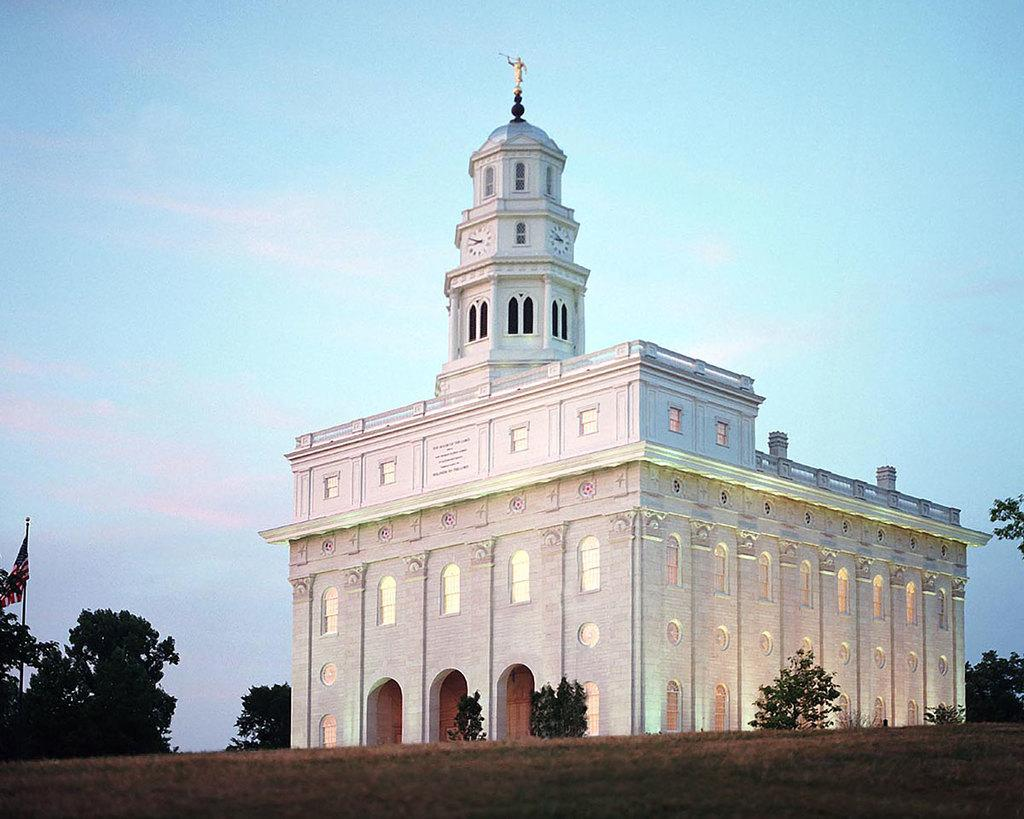What type of structure is visible in the image? There is a building in the image. What can be seen in front of the building? There are trees and a pole with a flag in front of the building. What is visible behind the building? The sky is visible behind the building. What type of guitar is being played in the image? There is no guitar present in the image. Can you tell me how many lamps are visible in the image? There are no lamps visible in the image. 